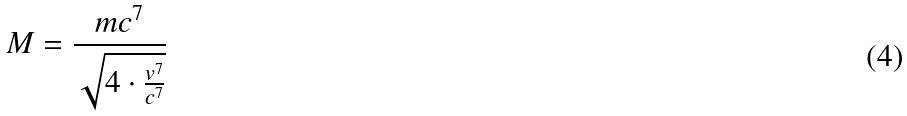Convert formula to latex. <formula><loc_0><loc_0><loc_500><loc_500>M = \frac { m c ^ { 7 } } { \sqrt { 4 \cdot \frac { v ^ { 7 } } { c ^ { 7 } } } }</formula> 